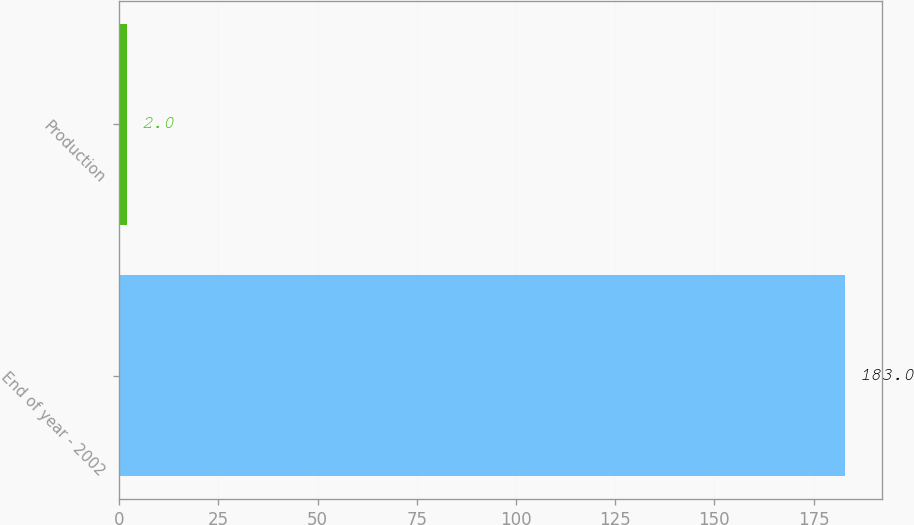Convert chart to OTSL. <chart><loc_0><loc_0><loc_500><loc_500><bar_chart><fcel>End of year - 2002<fcel>Production<nl><fcel>183<fcel>2<nl></chart> 